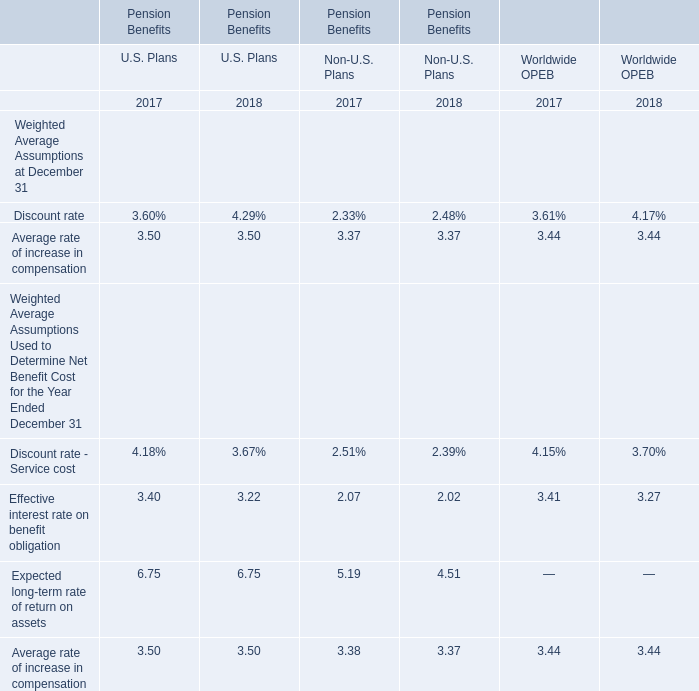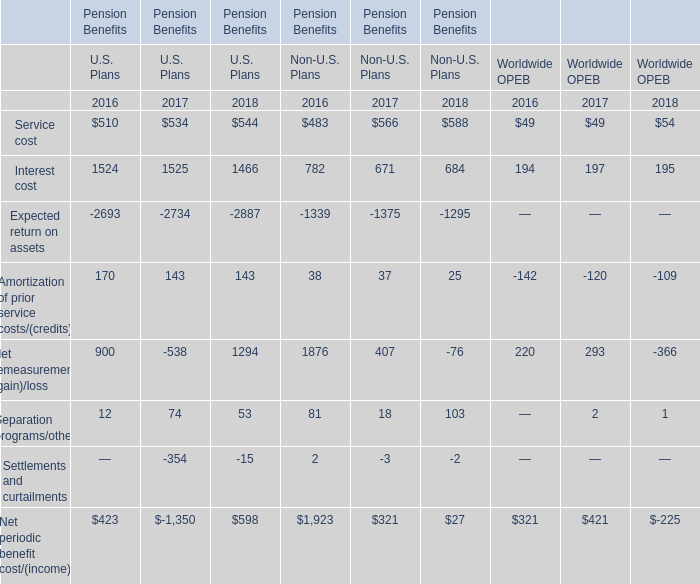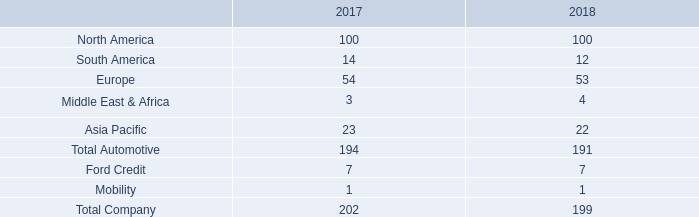What is the ratio of all U.S. Plans that are in the range of 0 and 200 to the sum of U.S. Plans, in 2016 for Pension Benefits? 
Computations: ((170 + 12) / (((((170 + 12) + 510) + 1524) - 2693) + 900))
Answer: 0.43026. 